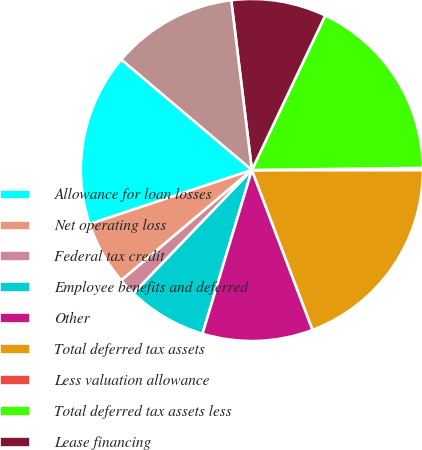<chart> <loc_0><loc_0><loc_500><loc_500><pie_chart><fcel>Allowance for loan losses<fcel>Net operating loss<fcel>Federal tax credit<fcel>Employee benefits and deferred<fcel>Other<fcel>Total deferred tax assets<fcel>Less valuation allowance<fcel>Total deferred tax assets less<fcel>Lease financing<fcel>Goodwill and intangibles<nl><fcel>16.29%<fcel>6.05%<fcel>1.66%<fcel>7.51%<fcel>10.44%<fcel>19.22%<fcel>0.2%<fcel>17.75%<fcel>8.98%<fcel>11.9%<nl></chart> 